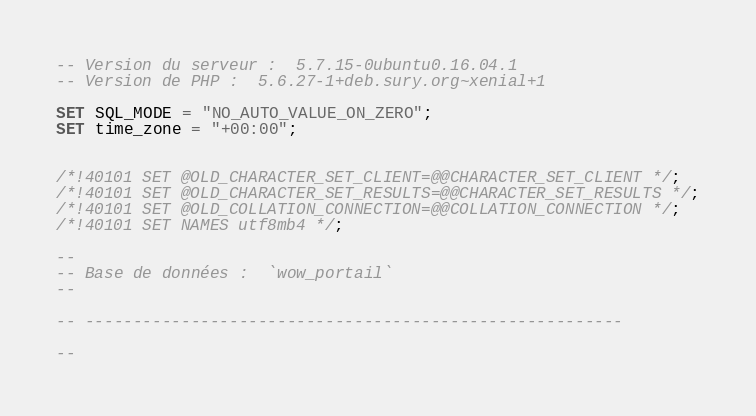Convert code to text. <code><loc_0><loc_0><loc_500><loc_500><_SQL_>-- Version du serveur :  5.7.15-0ubuntu0.16.04.1
-- Version de PHP :  5.6.27-1+deb.sury.org~xenial+1

SET SQL_MODE = "NO_AUTO_VALUE_ON_ZERO";
SET time_zone = "+00:00";


/*!40101 SET @OLD_CHARACTER_SET_CLIENT=@@CHARACTER_SET_CLIENT */;
/*!40101 SET @OLD_CHARACTER_SET_RESULTS=@@CHARACTER_SET_RESULTS */;
/*!40101 SET @OLD_COLLATION_CONNECTION=@@COLLATION_CONNECTION */;
/*!40101 SET NAMES utf8mb4 */;

--
-- Base de données :  `wow_portail`
--

-- --------------------------------------------------------

--</code> 